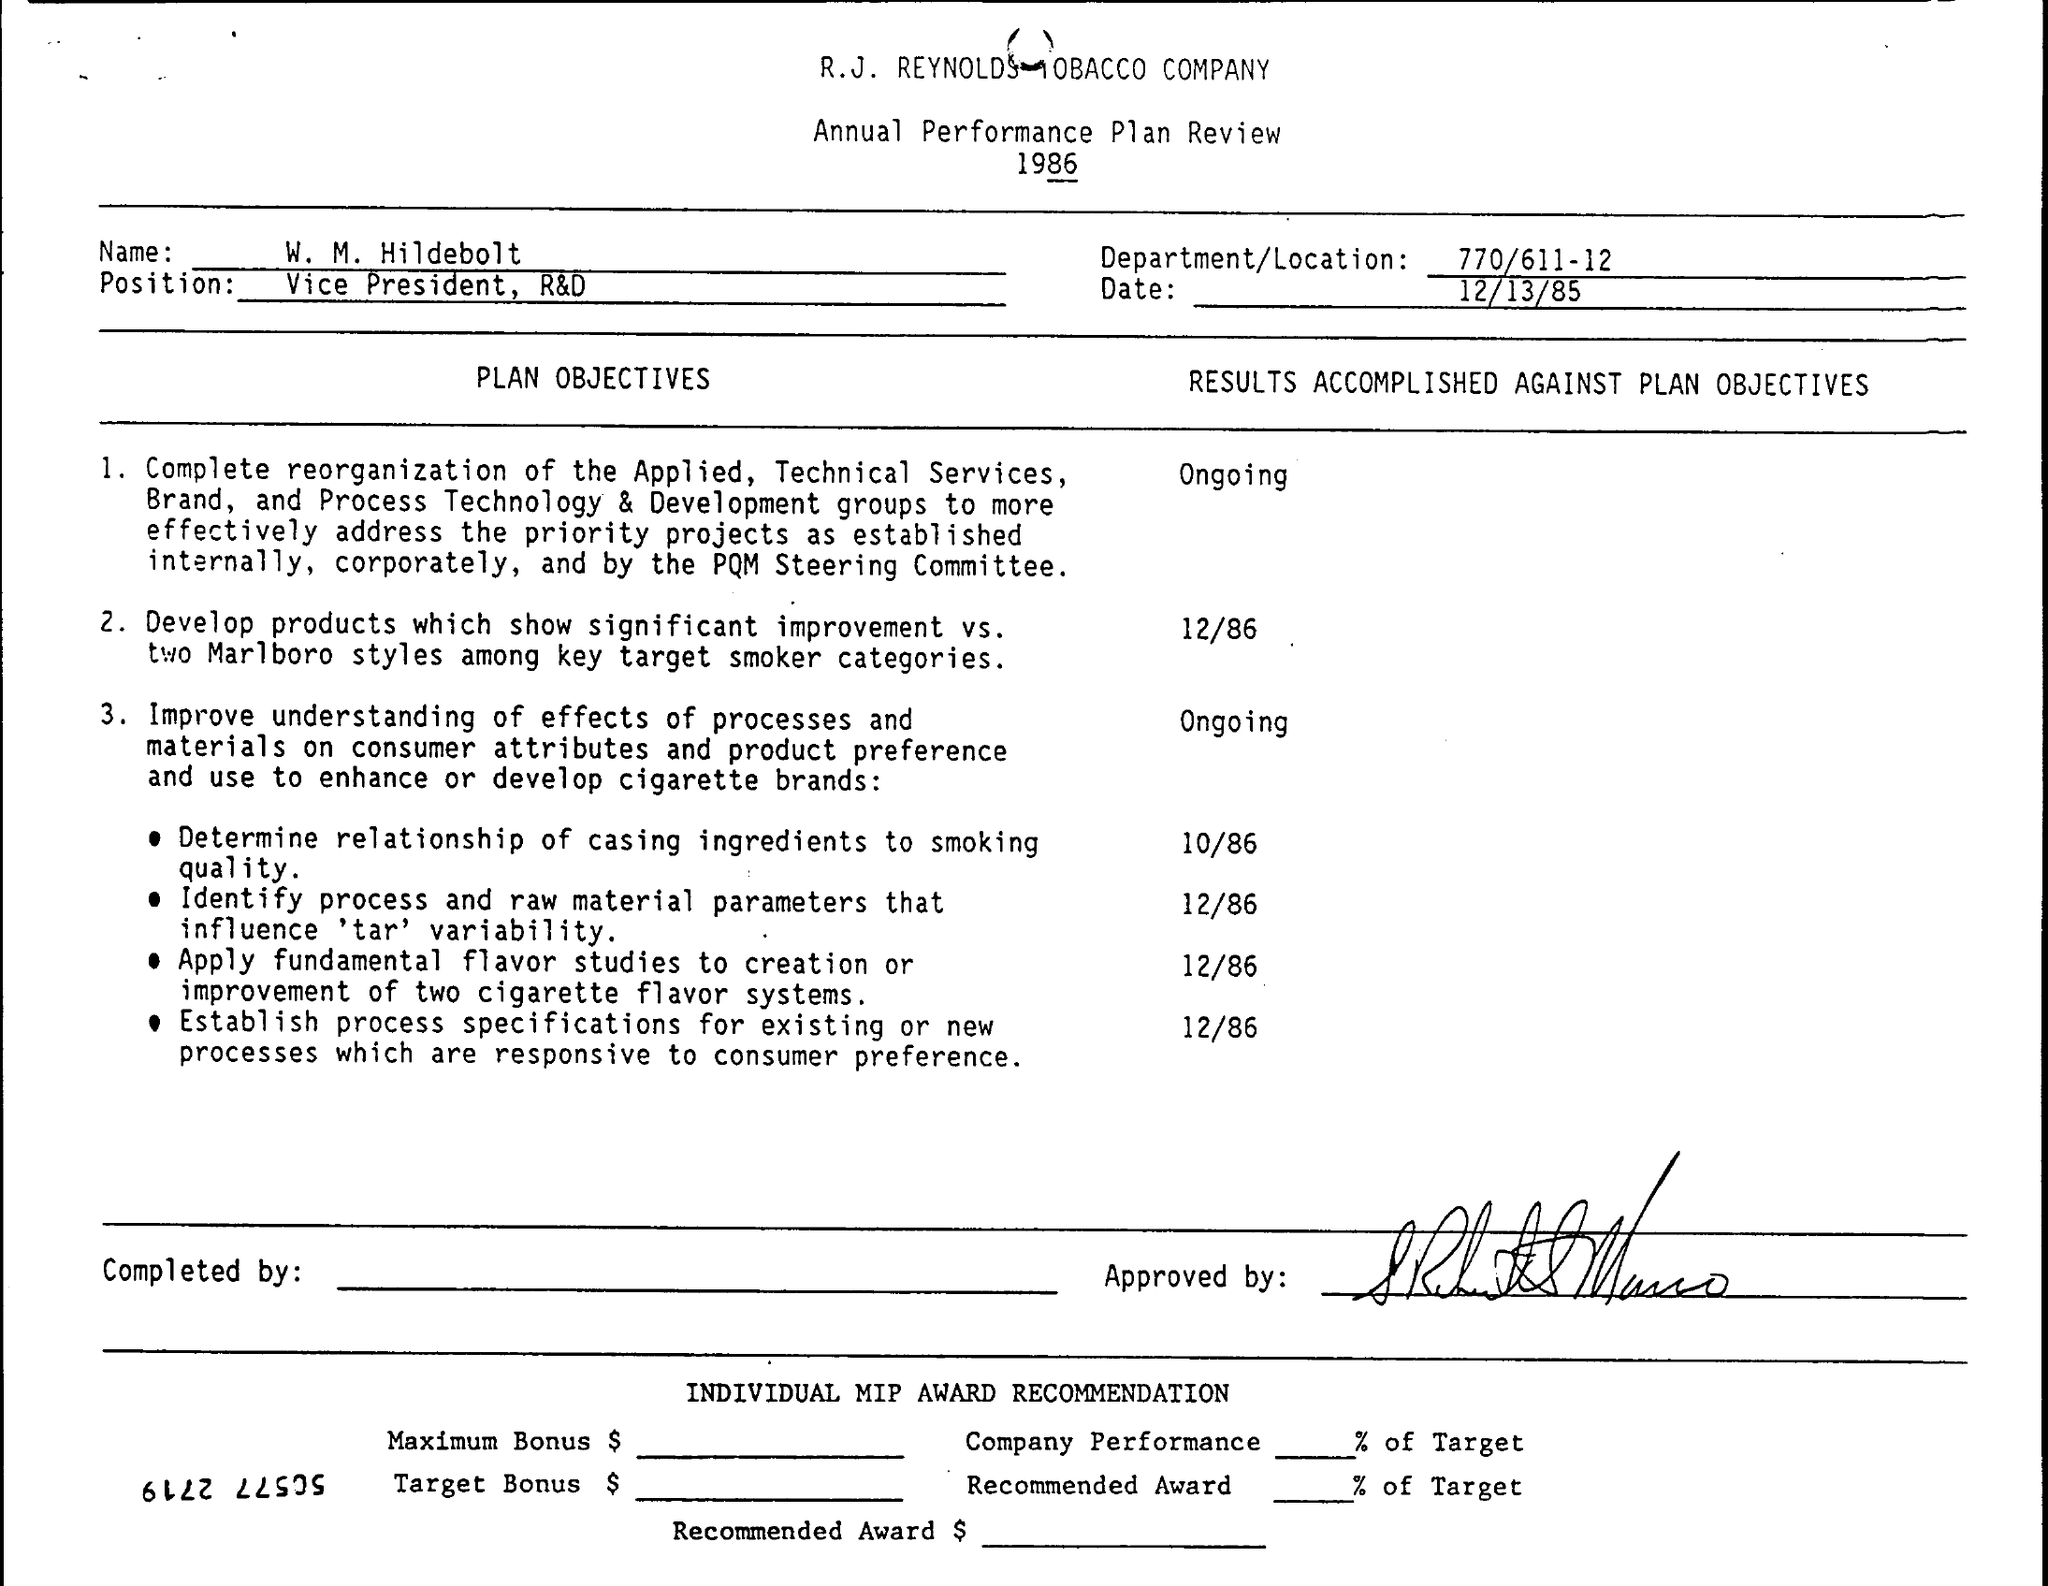To which year does this document belong?
Ensure brevity in your answer.  1986. What is the date mentioned?
Your answer should be very brief. 12/13/85. 